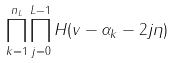<formula> <loc_0><loc_0><loc_500><loc_500>\prod _ { k = 1 } ^ { n _ { L } } \prod _ { j = 0 } ^ { L - 1 } H ( v - \alpha _ { k } - 2 j \eta )</formula> 